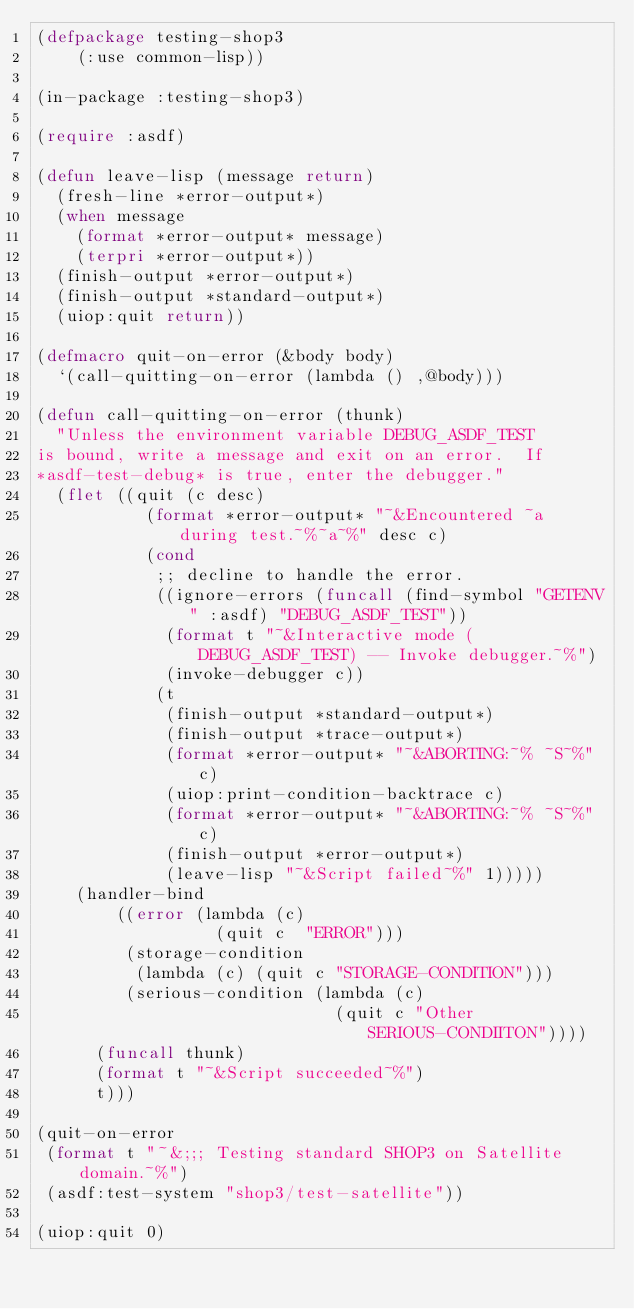<code> <loc_0><loc_0><loc_500><loc_500><_Lisp_>(defpackage testing-shop3
    (:use common-lisp))

(in-package :testing-shop3)

(require :asdf)

(defun leave-lisp (message return)
  (fresh-line *error-output*)
  (when message
    (format *error-output* message)
    (terpri *error-output*))
  (finish-output *error-output*)
  (finish-output *standard-output*)
  (uiop:quit return))

(defmacro quit-on-error (&body body)
  `(call-quitting-on-error (lambda () ,@body)))

(defun call-quitting-on-error (thunk)
  "Unless the environment variable DEBUG_ASDF_TEST
is bound, write a message and exit on an error.  If
*asdf-test-debug* is true, enter the debugger."
  (flet ((quit (c desc)
           (format *error-output* "~&Encountered ~a during test.~%~a~%" desc c)
           (cond
            ;; decline to handle the error.
            ((ignore-errors (funcall (find-symbol "GETENV" :asdf) "DEBUG_ASDF_TEST"))
             (format t "~&Interactive mode (DEBUG_ASDF_TEST) -- Invoke debugger.~%")
             (invoke-debugger c))
            (t
             (finish-output *standard-output*)
             (finish-output *trace-output*)
             (format *error-output* "~&ABORTING:~% ~S~%" c)
             (uiop:print-condition-backtrace c)
             (format *error-output* "~&ABORTING:~% ~S~%" c)
             (finish-output *error-output*)
             (leave-lisp "~&Script failed~%" 1)))))
    (handler-bind
        ((error (lambda (c)
                  (quit c  "ERROR")))
         (storage-condition
          (lambda (c) (quit c "STORAGE-CONDITION")))
         (serious-condition (lambda (c)
                              (quit c "Other SERIOUS-CONDIITON"))))
      (funcall thunk)
      (format t "~&Script succeeded~%")
      t)))

(quit-on-error
 (format t "~&;;; Testing standard SHOP3 on Satellite domain.~%")
 (asdf:test-system "shop3/test-satellite"))

(uiop:quit 0)
</code> 